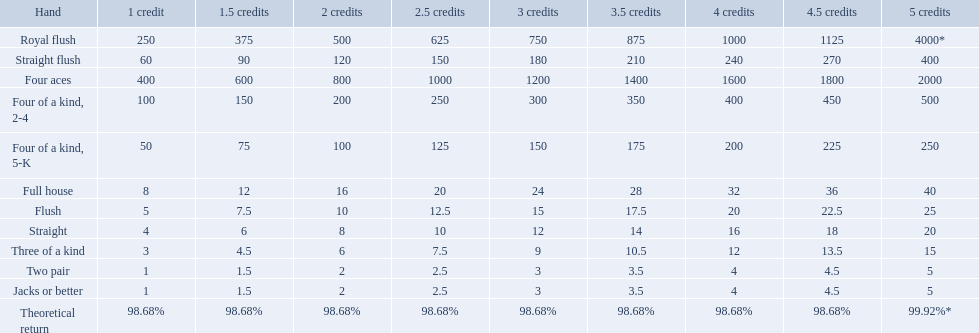What are the hands? Royal flush, Straight flush, Four aces, Four of a kind, 2-4, Four of a kind, 5-K, Full house, Flush, Straight, Three of a kind, Two pair, Jacks or better. Which hand is on the top? Royal flush. What are the hands? Royal flush, Straight flush, Four aces, Four of a kind, 2-4, Four of a kind, 5-K, Full house, Flush, Straight, Three of a kind, Two pair, Jacks or better. Which hand is on the top? Royal flush. What are the hands? Royal flush, Straight flush, Four aces, Four of a kind, 2-4, Four of a kind, 5-K, Full house, Flush, Straight, Three of a kind, Two pair, Jacks or better. Which hand is on the top? Royal flush. What are the hands in super aces? Royal flush, Straight flush, Four aces, Four of a kind, 2-4, Four of a kind, 5-K, Full house, Flush, Straight, Three of a kind, Two pair, Jacks or better. What hand gives the highest credits? Royal flush. What are the hands in super aces? Royal flush, Straight flush, Four aces, Four of a kind, 2-4, Four of a kind, 5-K, Full house, Flush, Straight, Three of a kind, Two pair, Jacks or better. What hand gives the highest credits? Royal flush. Which hand is the third best hand in the card game super aces? Four aces. Which hand is the second best hand? Straight flush. Which hand had is the best hand? Royal flush. Which hand is the third best hand in the card game super aces? Four aces. Which hand is the second best hand? Straight flush. Which hand had is the best hand? Royal flush. What are the top 5 best types of hand for winning? Royal flush, Straight flush, Four aces, Four of a kind, 2-4, Four of a kind, 5-K. Between those 5, which of those hands are four of a kind? Four of a kind, 2-4, Four of a kind, 5-K. Of those 2 hands, which is the best kind of four of a kind for winning? Four of a kind, 2-4. What is the values in the 5 credits area? 4000*, 400, 2000, 500, 250, 40, 25, 20, 15, 5, 5. Which of these is for a four of a kind? 500, 250. Can you give me this table as a dict? {'header': ['Hand', '1 credit', '1.5 credits', '2 credits', '2.5 credits', '3 credits', '3.5 credits', '4 credits', '4.5 credits', '5 credits'], 'rows': [['Royal flush', '250', '375', '500', '625', '750', '875', '1000', '1125', '4000*'], ['Straight flush', '60', '90', '120', '150', '180', '210', '240', '270', '400'], ['Four aces', '400', '600', '800', '1000', '1200', '1400', '1600', '1800', '2000'], ['Four of a kind, 2-4', '100', '150', '200', '250', '300', '350', '400', '450', '500'], ['Four of a kind, 5-K', '50', '75', '100', '125', '150', '175', '200', '225', '250'], ['Full house', '8', '12', '16', '20', '24', '28', '32', '36', '40'], ['Flush', '5', '7.5', '10', '12.5', '15', '17.5', '20', '22.5', '25'], ['Straight', '4', '6', '8', '10', '12', '14', '16', '18', '20'], ['Three of a kind', '3', '4.5', '6', '7.5', '9', '10.5', '12', '13.5', '15'], ['Two pair', '1', '1.5', '2', '2.5', '3', '3.5', '4', '4.5', '5'], ['Jacks or better', '1', '1.5', '2', '2.5', '3', '3.5', '4', '4.5', '5'], ['Theoretical return', '98.68%', '98.68%', '98.68%', '98.68%', '98.68%', '98.68%', '98.68%', '98.68%', '99.92%*']]} What is the higher value? 500. What hand is this for Four of a kind, 2-4. What is the higher amount of points for one credit you can get from the best four of a kind 100. What type is it? Four of a kind, 2-4. What is the higher amount of points for one credit you can get from the best four of a kind 100. What type is it? Four of a kind, 2-4. Which hand is lower than straight flush? Four aces. Which hand is lower than four aces? Four of a kind, 2-4. Which hand is higher out of straight and flush? Flush. Can you give me this table as a dict? {'header': ['Hand', '1 credit', '1.5 credits', '2 credits', '2.5 credits', '3 credits', '3.5 credits', '4 credits', '4.5 credits', '5 credits'], 'rows': [['Royal flush', '250', '375', '500', '625', '750', '875', '1000', '1125', '4000*'], ['Straight flush', '60', '90', '120', '150', '180', '210', '240', '270', '400'], ['Four aces', '400', '600', '800', '1000', '1200', '1400', '1600', '1800', '2000'], ['Four of a kind, 2-4', '100', '150', '200', '250', '300', '350', '400', '450', '500'], ['Four of a kind, 5-K', '50', '75', '100', '125', '150', '175', '200', '225', '250'], ['Full house', '8', '12', '16', '20', '24', '28', '32', '36', '40'], ['Flush', '5', '7.5', '10', '12.5', '15', '17.5', '20', '22.5', '25'], ['Straight', '4', '6', '8', '10', '12', '14', '16', '18', '20'], ['Three of a kind', '3', '4.5', '6', '7.5', '9', '10.5', '12', '13.5', '15'], ['Two pair', '1', '1.5', '2', '2.5', '3', '3.5', '4', '4.5', '5'], ['Jacks or better', '1', '1.5', '2', '2.5', '3', '3.5', '4', '4.5', '5'], ['Theoretical return', '98.68%', '98.68%', '98.68%', '98.68%', '98.68%', '98.68%', '98.68%', '98.68%', '99.92%*']]} Which hand is lower than straight flush? Four aces. Which hand is lower than four aces? Four of a kind, 2-4. Which hand is higher out of straight and flush? Flush. What are the different hands? Royal flush, Straight flush, Four aces, Four of a kind, 2-4, Four of a kind, 5-K, Full house, Flush, Straight, Three of a kind, Two pair, Jacks or better. Which hands have a higher standing than a straight? Royal flush, Straight flush, Four aces, Four of a kind, 2-4, Four of a kind, 5-K, Full house, Flush. Of these, which hand is the next highest after a straight? Flush. What are the different hands? Royal flush, Straight flush, Four aces, Four of a kind, 2-4, Four of a kind, 5-K, Full house, Flush, Straight, Three of a kind, Two pair, Jacks or better. Which hands have a higher standing than a straight? Royal flush, Straight flush, Four aces, Four of a kind, 2-4, Four of a kind, 5-K, Full house, Flush. Of these, which hand is the next highest after a straight? Flush. 